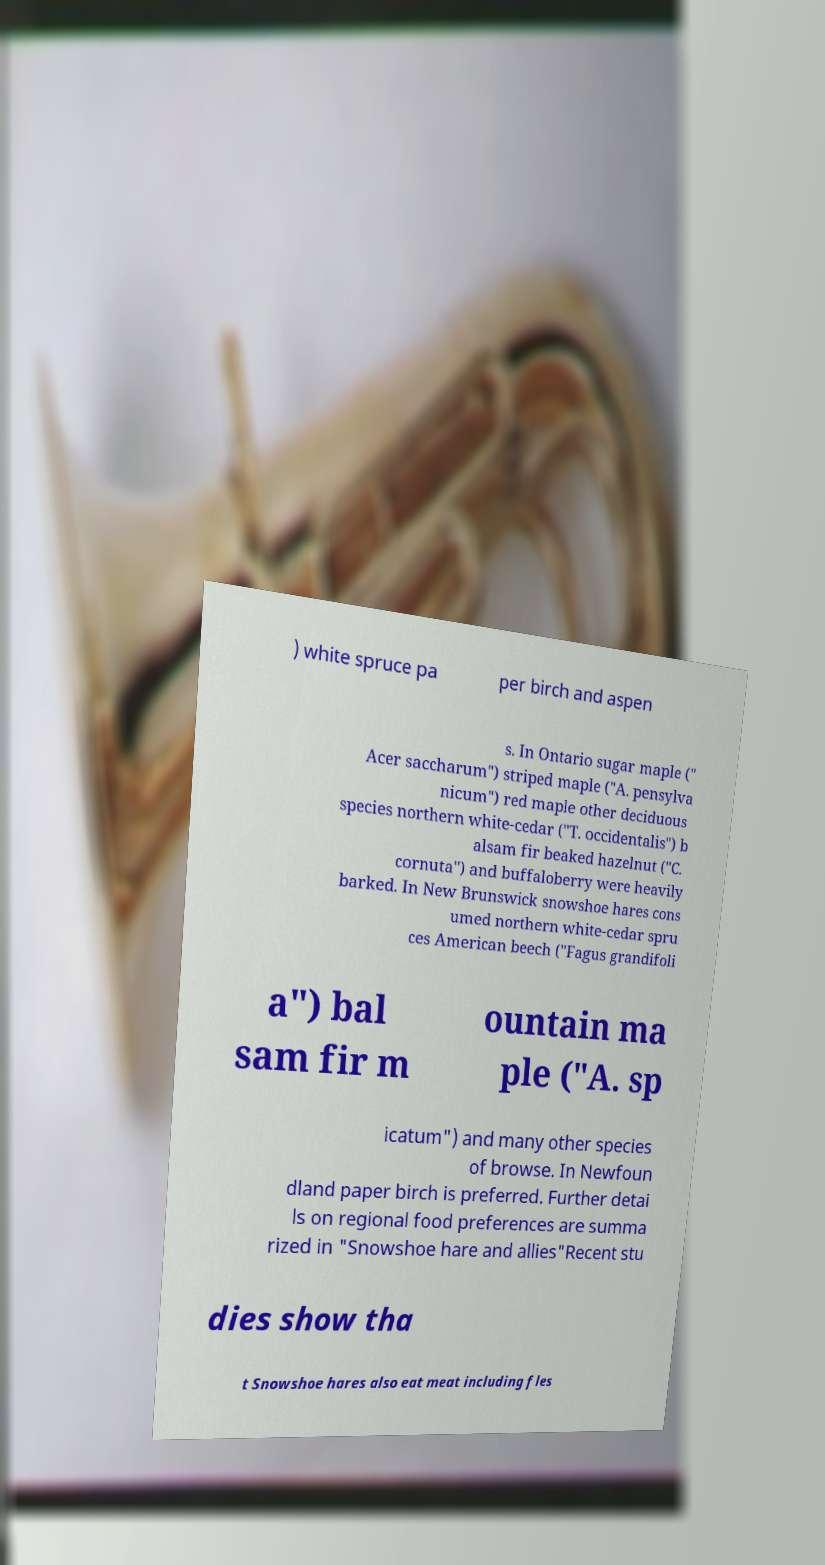Can you read and provide the text displayed in the image?This photo seems to have some interesting text. Can you extract and type it out for me? ) white spruce pa per birch and aspen s. In Ontario sugar maple (" Acer saccharum") striped maple ("A. pensylva nicum") red maple other deciduous species northern white-cedar ("T. occidentalis") b alsam fir beaked hazelnut ("C. cornuta") and buffaloberry were heavily barked. In New Brunswick snowshoe hares cons umed northern white-cedar spru ces American beech ("Fagus grandifoli a") bal sam fir m ountain ma ple ("A. sp icatum") and many other species of browse. In Newfoun dland paper birch is preferred. Further detai ls on regional food preferences are summa rized in "Snowshoe hare and allies"Recent stu dies show tha t Snowshoe hares also eat meat including fles 